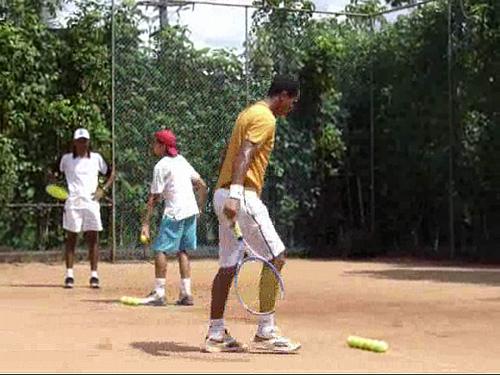What game are these people playing?
Keep it brief. Tennis. What's on the ground?
Keep it brief. Balls. Are there lines painted on the court?
Quick response, please. No. 